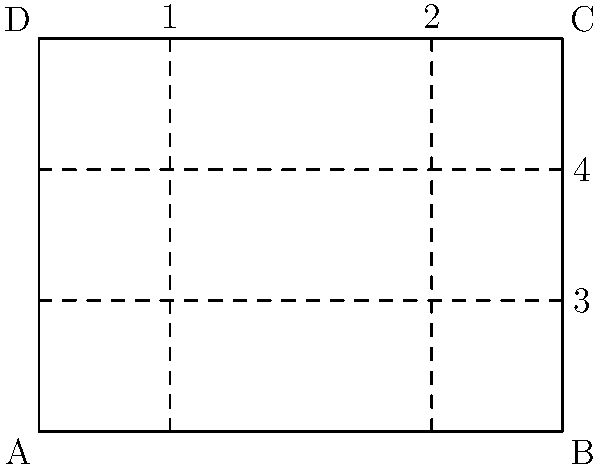Imagine you're holding a rectangular law book cover that can be folded along the dotted lines shown in the diagram. If you fold along lines 1 and 2 towards the center, and then fold the resulting shape along lines 3 and 4 towards the back, what shape will the folded cover resemble? Let's approach this step-by-step:

1. First, we fold along lines 1 and 2 towards the center. This creates three vertical sections of equal width.

2. After this first fold, the shape becomes a rectangle that is one-third the width of the original cover but maintains its original height.

3. Next, we fold along lines 3 and 4 towards the back. These lines divide the height of the cover into three equal parts.

4. When we fold along these lines, we're essentially folding the top third and bottom third towards the back, leaving only the middle third visible from the front.

5. After completing both sets of folds, we're left with a shape that is one-third the width and one-third the height of the original cover.

6. Given that the original shape was a rectangle, and we've reduced both dimensions equally by a factor of 3, the resulting shape will maintain the same proportions as the original cover.

Therefore, the folded cover will resemble a smaller rectangle with the same proportions as the original cover.
Answer: A smaller rectangle 